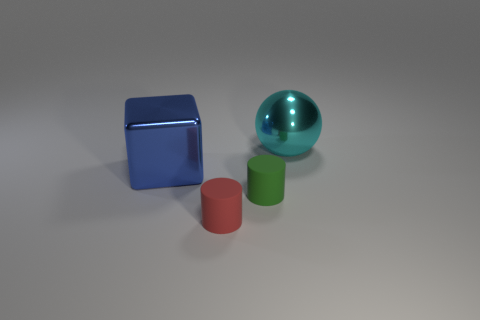Add 2 rubber cylinders. How many objects exist? 6 Subtract all cubes. How many objects are left? 3 Subtract all red objects. Subtract all yellow matte blocks. How many objects are left? 3 Add 3 big cyan shiny objects. How many big cyan shiny objects are left? 4 Add 3 big red objects. How many big red objects exist? 3 Subtract 0 yellow balls. How many objects are left? 4 